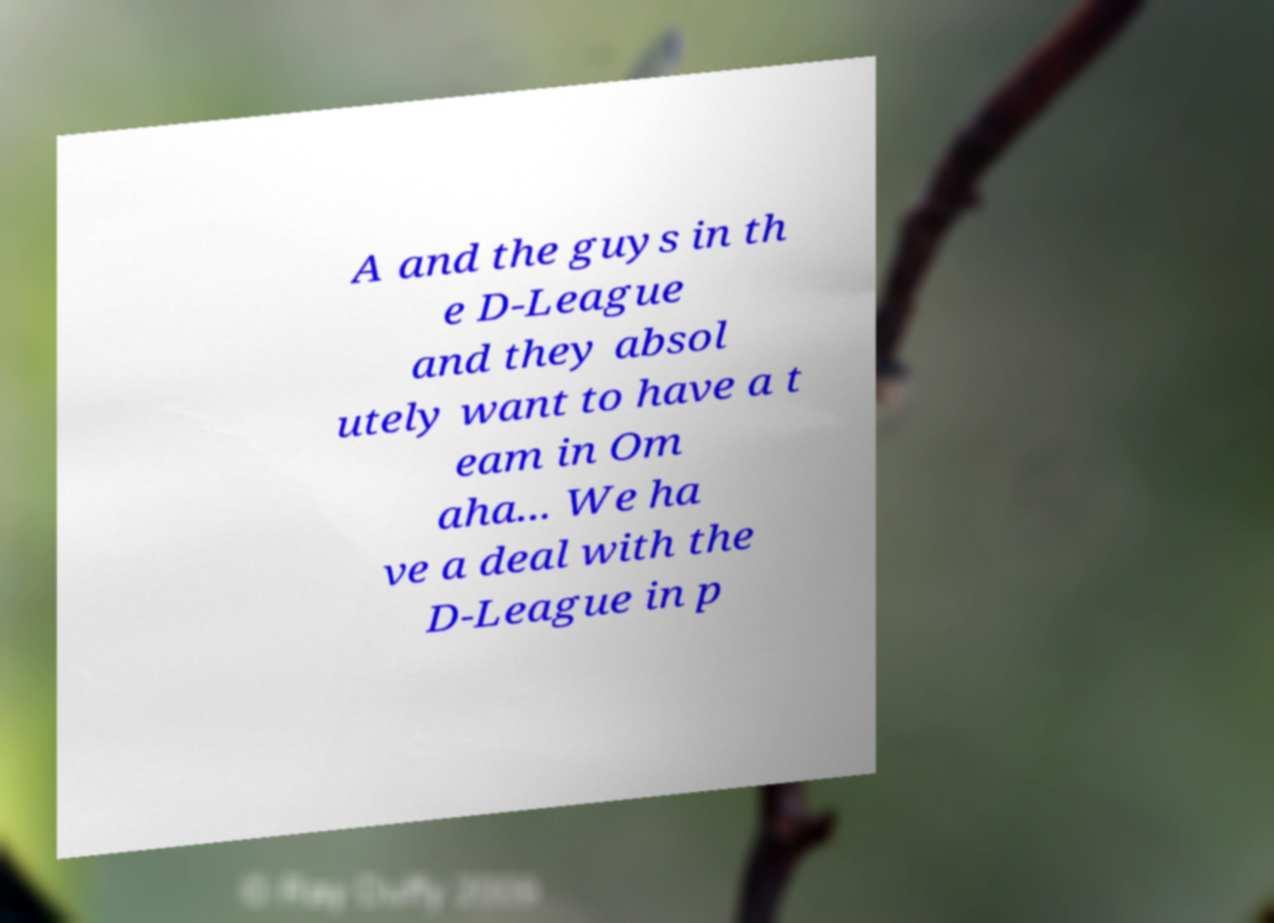Could you assist in decoding the text presented in this image and type it out clearly? A and the guys in th e D-League and they absol utely want to have a t eam in Om aha... We ha ve a deal with the D-League in p 